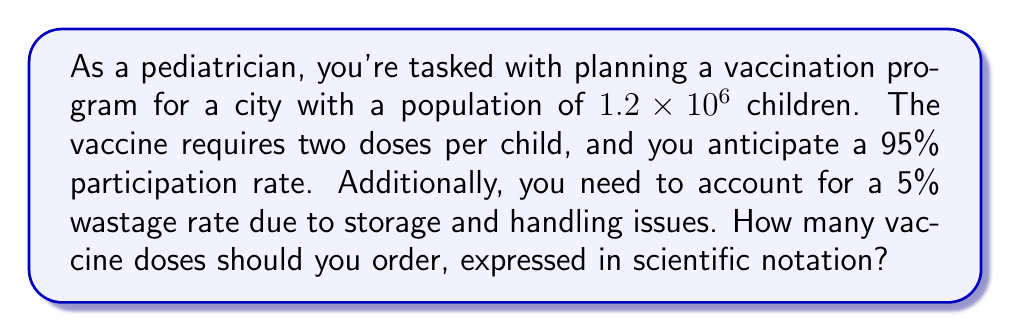Solve this math problem. Let's break this down step-by-step:

1) First, calculate the number of children who will participate:
   $1.2 \times 10^6 \times 0.95 = 1.14 \times 10^6$ children

2) Each child needs two doses, so multiply by 2:
   $1.14 \times 10^6 \times 2 = 2.28 \times 10^6$ doses

3) Now, account for the 5% wastage. We need to increase our order by 5%:
   $2.28 \times 10^6 \times 1.05 = 2.394 \times 10^6$ doses

4) Round up to ensure we have enough doses:
   $2.394 \times 10^6$ rounds to $2.4 \times 10^6$ doses

This calculation ensures that we have enough doses to vaccinate all participating children, even accounting for potential wastage, while respecting parental autonomy through the voluntary participation rate.
Answer: $2.4 \times 10^6$ doses 